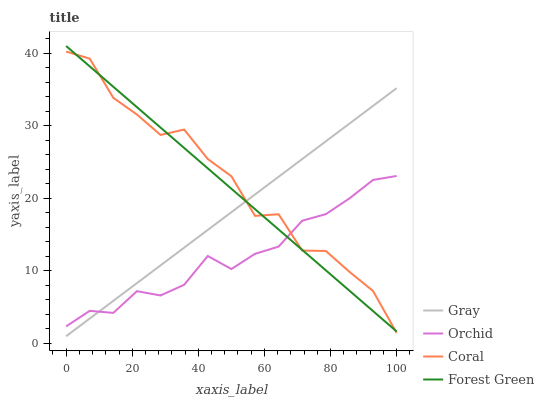Does Orchid have the minimum area under the curve?
Answer yes or no. Yes. Does Coral have the maximum area under the curve?
Answer yes or no. Yes. Does Forest Green have the minimum area under the curve?
Answer yes or no. No. Does Forest Green have the maximum area under the curve?
Answer yes or no. No. Is Gray the smoothest?
Answer yes or no. Yes. Is Coral the roughest?
Answer yes or no. Yes. Is Forest Green the smoothest?
Answer yes or no. No. Is Forest Green the roughest?
Answer yes or no. No. Does Gray have the lowest value?
Answer yes or no. Yes. Does Coral have the lowest value?
Answer yes or no. No. Does Forest Green have the highest value?
Answer yes or no. Yes. Does Coral have the highest value?
Answer yes or no. No. Does Gray intersect Orchid?
Answer yes or no. Yes. Is Gray less than Orchid?
Answer yes or no. No. Is Gray greater than Orchid?
Answer yes or no. No. 